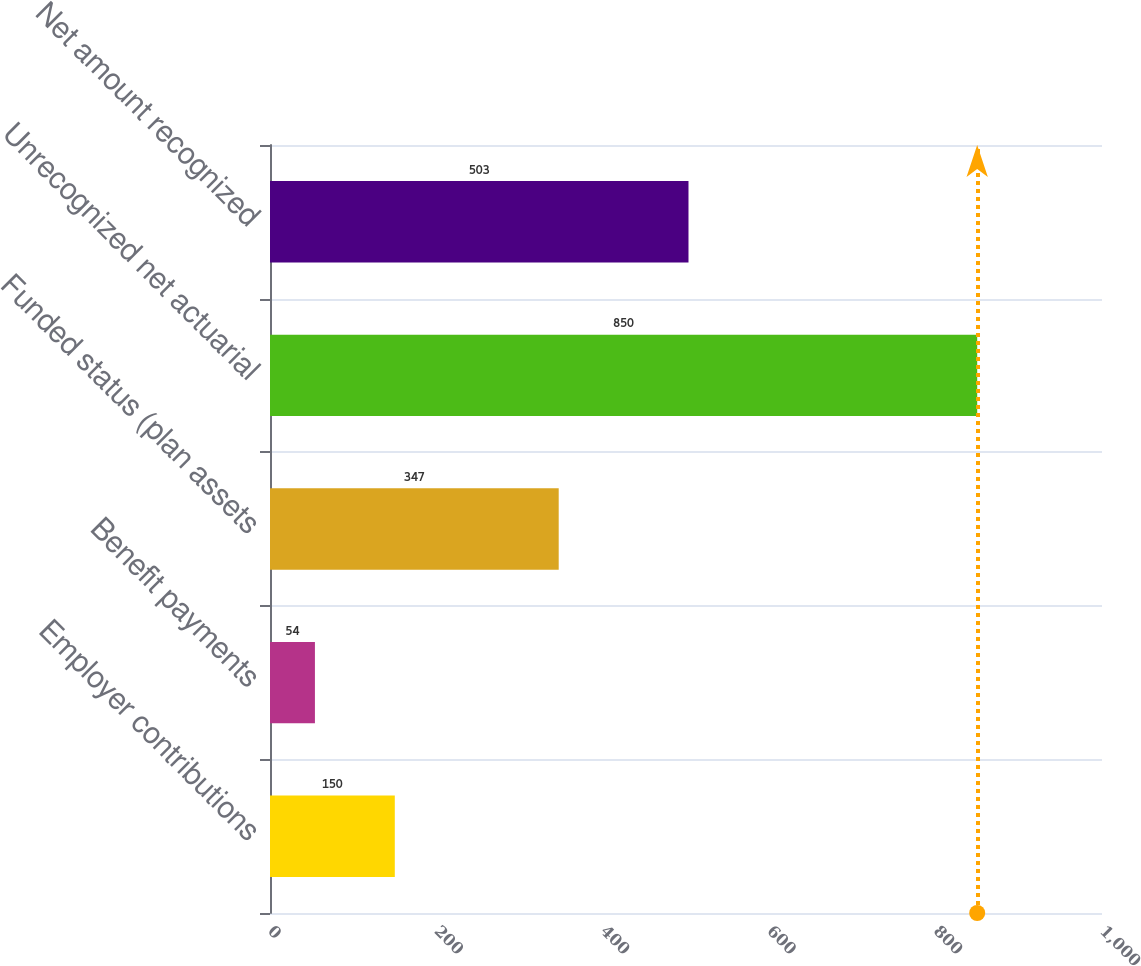Convert chart. <chart><loc_0><loc_0><loc_500><loc_500><bar_chart><fcel>Employer contributions<fcel>Benefit payments<fcel>Funded status (plan assets<fcel>Unrecognized net actuarial<fcel>Net amount recognized<nl><fcel>150<fcel>54<fcel>347<fcel>850<fcel>503<nl></chart> 